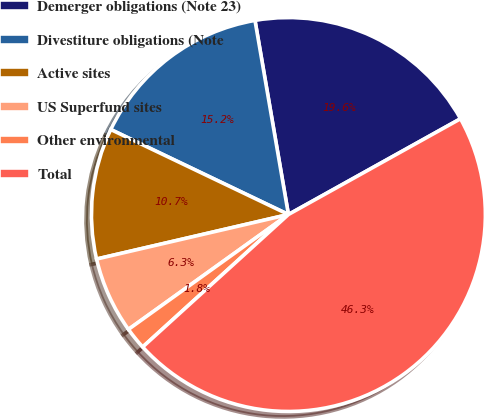Convert chart. <chart><loc_0><loc_0><loc_500><loc_500><pie_chart><fcel>Demerger obligations (Note 23)<fcel>Divestiture obligations (Note<fcel>Active sites<fcel>US Superfund sites<fcel>Other environmental<fcel>Total<nl><fcel>19.63%<fcel>15.18%<fcel>10.73%<fcel>6.28%<fcel>1.83%<fcel>46.33%<nl></chart> 